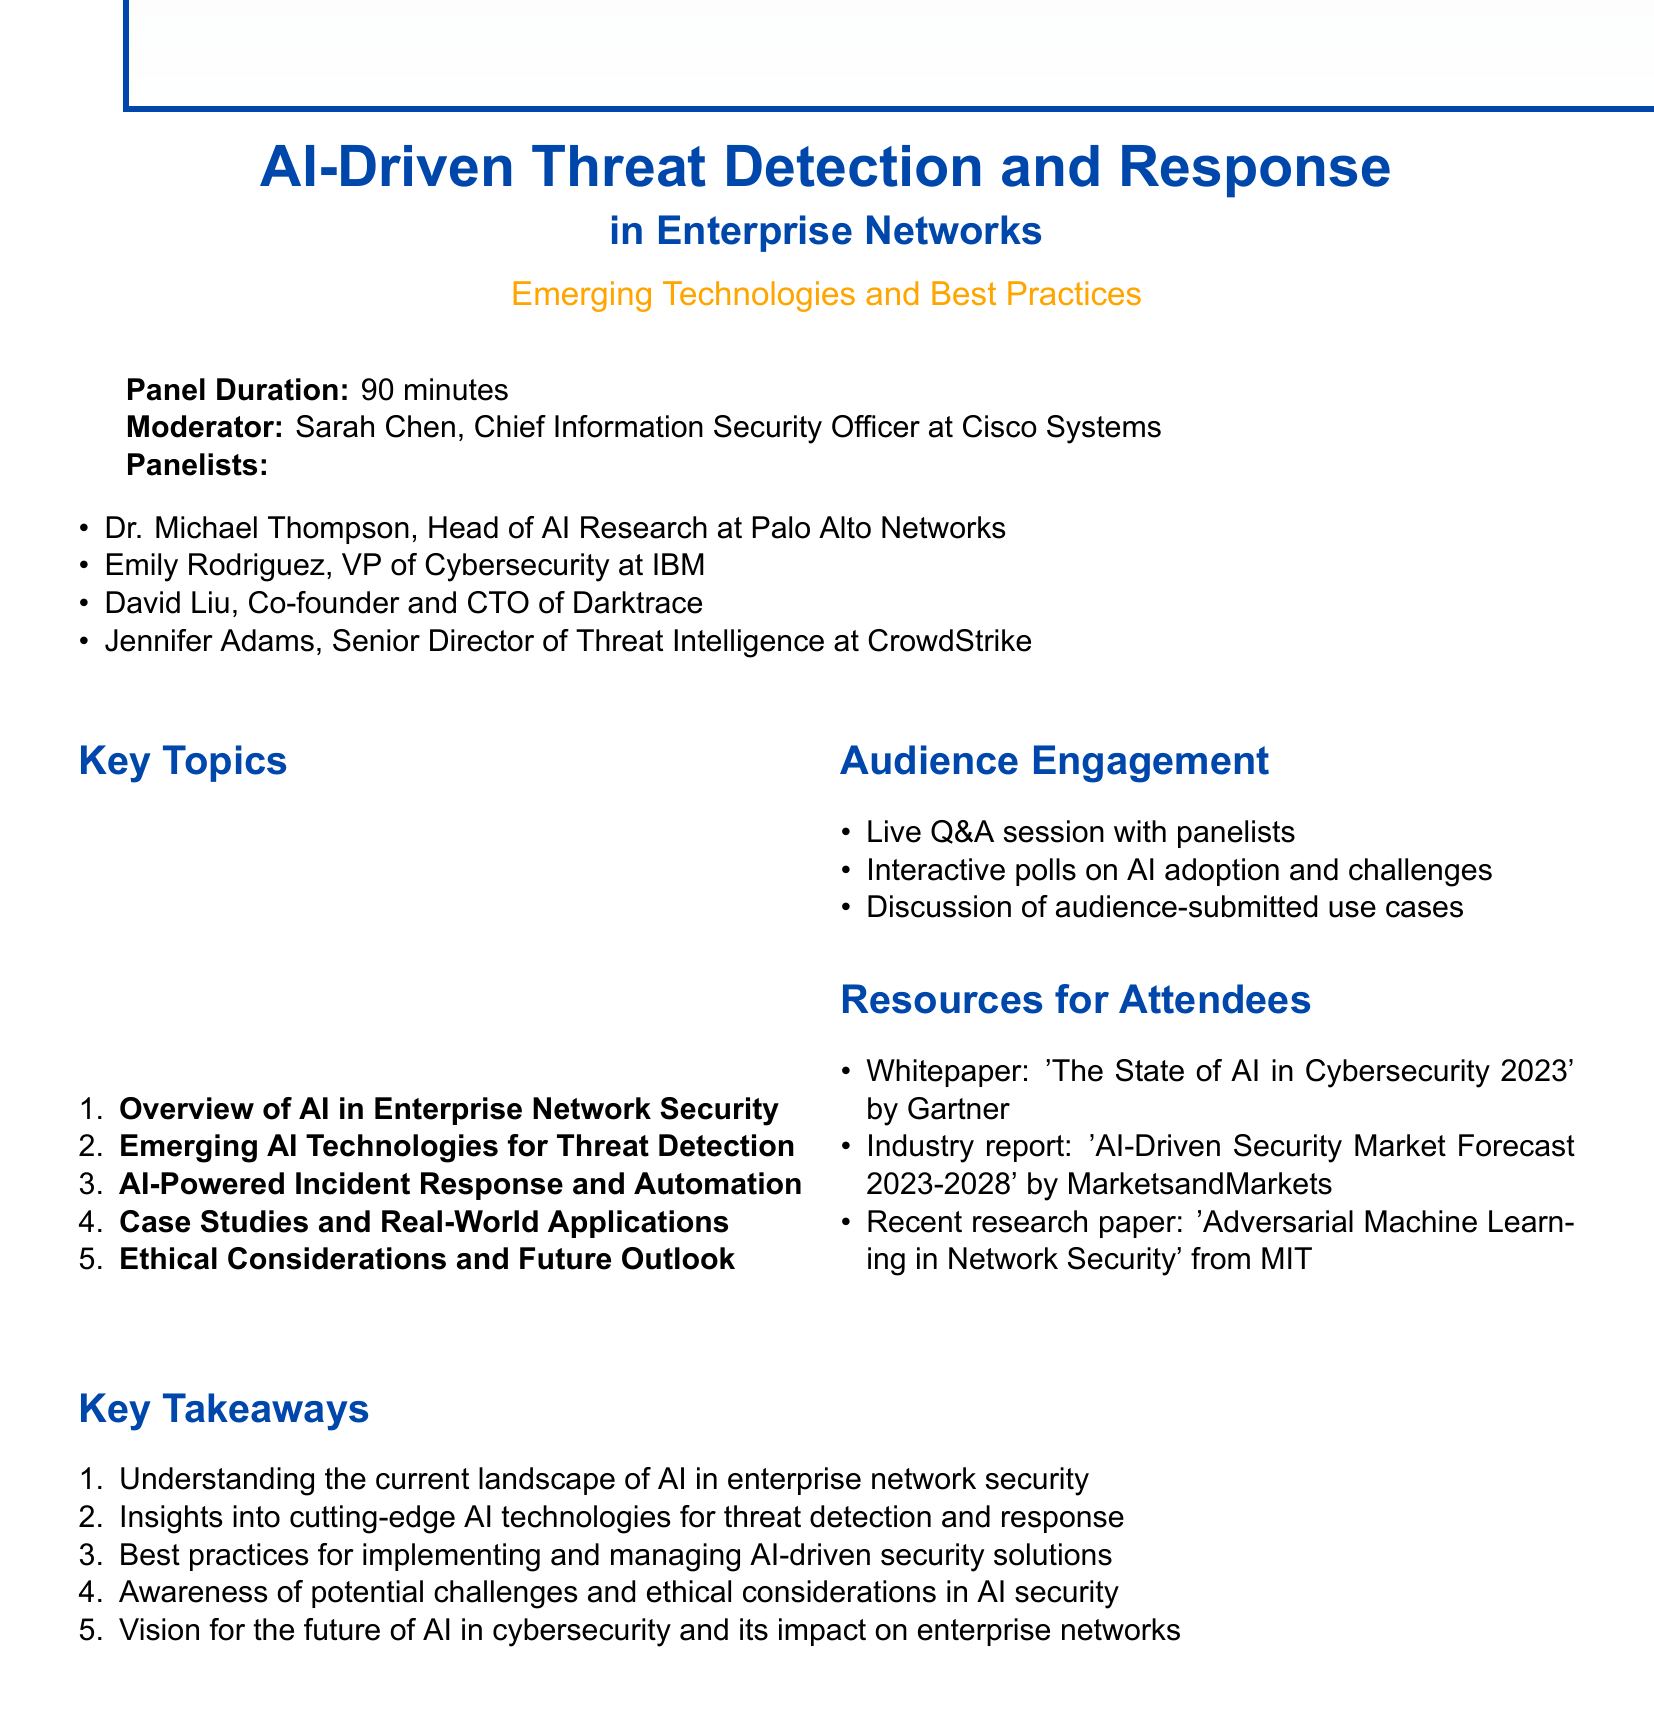What is the title of the panel? The title is explicitly stated in the document as "AI-Driven Threat Detection and Response in Enterprise Networks: Emerging Technologies and Best Practices."
Answer: AI-Driven Threat Detection and Response in Enterprise Networks: Emerging Technologies and Best Practices Who is the moderator of the panel? The document lists Sarah Chen as the moderator, along with her title at Cisco Systems.
Answer: Sarah Chen How many minutes is the panel scheduled for? The document specifies that the panel duration is 90 minutes.
Answer: 90 minutes Name one emerging AI technology for threat detection discussed in the panel. The document lists several subtopics, one of which is "Machine learning algorithms for anomaly detection."
Answer: Machine learning algorithms for anomaly detection What is one of the key takeaways mentioned in the document? The key takeaways are summarized, and one listed is "Understanding the current landscape of AI in enterprise network security."
Answer: Understanding the current landscape of AI in enterprise network security Who is the Co-founder and CTO of Darktrace? The document provides a list of panelists, identifying David Liu as the Co-founder and CTO of Darktrace.
Answer: David Liu What type of session is planned for audience engagement? The document indicates a "Live Q&A session with panelists" as part of the audience engagement activities.
Answer: Live Q&A session What is one resource provided for attendees? The document mentions multiple resources for attendees, including the whitepaper titled "The State of AI in Cybersecurity 2023" by Gartner.
Answer: Whitepaper: 'The State of AI in Cybersecurity 2023' by Gartner Which panelist is the VP of Cybersecurity at IBM? The panelist list identifies Emily Rodriguez explicitly as the VP of Cybersecurity at IBM.
Answer: Emily Rodriguez 